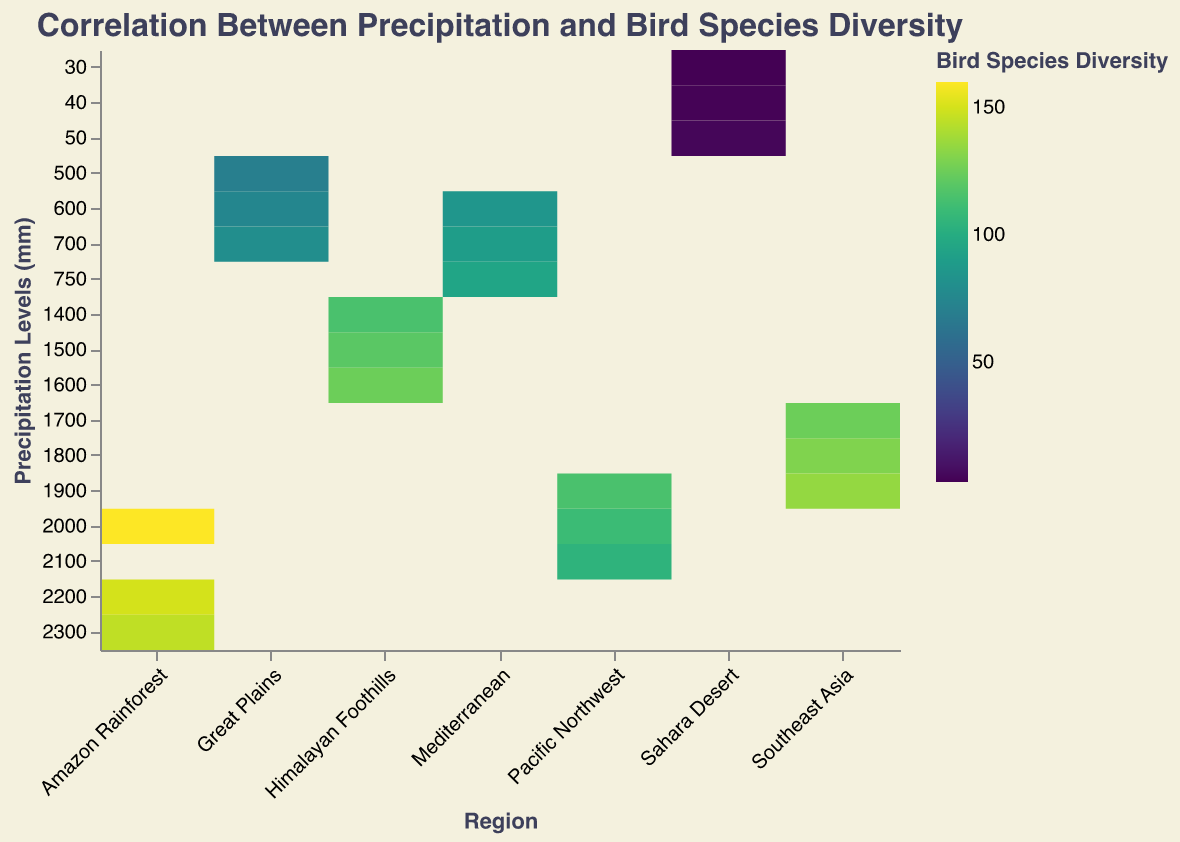What is the title of the heatmap? The title is typically found at the top of the heatmap and is meant to provide an overview of what the graph is representing. In this case, the title specifies the correlation between precipitation levels and bird species diversity.
Answer: Correlation Between Precipitation and Bird Species Diversity Which region has the highest bird species diversity at 2200 mm of precipitation? To find the answer, locate the column for the "Amazon Rainforest" and then search for the cell corresponding to 2200 mm of precipitation. Check the color intensity that represents bird species diversity. The tooltip can provide a numeric value for verification.
Answer: Amazon Rainforest How does bird species diversity change in the Sahara Desert as precipitation levels increase? Observe the cells in the "Sahara Desert" column and note the change in bird species diversity as precipitation levels increase from 30 mm to 50 mm.
Answer: It slightly increases from 3 to 5 Which region exhibits the least bird species diversity overall? Compare the color intensity of the cells corresponding to each region, focusing on the regions with the lightest colors which indicate lower bird species diversity. The tooltip can help to confirm the values.
Answer: Sahara Desert What is the general trend of bird species diversity in the Great Plains region as precipitation levels rise from 500 mm to 700 mm? Look at the cells under the "Great Plains" column and check the gradient in color from 500 mm to 700 mm. A deeper color indicates higher diversity.
Answer: It increases Compare the bird species diversity between the Amazon Rainforest and the Mediterranean regions at their respective highest precipitation levels. Locate the top precipitation level for Amazon Rainforest (2300 mm) and Mediterranean (750 mm), then compare the colors representing species diversity at these points. The tooltip offers exact numeric values if needed.
Answer: Higher in Amazon Rainforest What is the relationship between precipitation levels and bird species diversity in the Pacific Northwest? Examine the cells under the "Pacific Northwest" column and see how the colors change with different precipitation levels.
Answer: Positive correlation Which region has the most consistent bird species diversity across different precipitation levels? Look for the region whose cells display the most uniform color gradient across different precipitation levels. The tooltip can confirm the consistency of values.
Answer: Southeast Asia What is the dominant color scheme used in the heatmap? Observe the overall color scheme used to represent different intensities of bird species diversity.
Answer: Viridis Identify the region with the highest variability in bird species diversity across different precipitation levels. Evaluate which column shows the most diverse color changes, indicating significant differences in bird species diversity across precipitation levels. Use the tooltip for precise comparisons.
Answer: Amazon Rainforest 